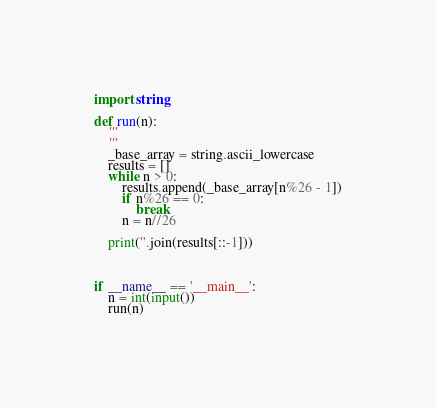Convert code to text. <code><loc_0><loc_0><loc_500><loc_500><_Python_>import string

def run(n):
    '''
    '''
    _base_array = string.ascii_lowercase
    results = []
    while n > 0:
        results.append(_base_array[n%26 - 1])
        if n%26 == 0:
            break
        n = n//26

    print(''.join(results[::-1]))



if __name__ == '__main__':
    n = int(input())
    run(n)</code> 